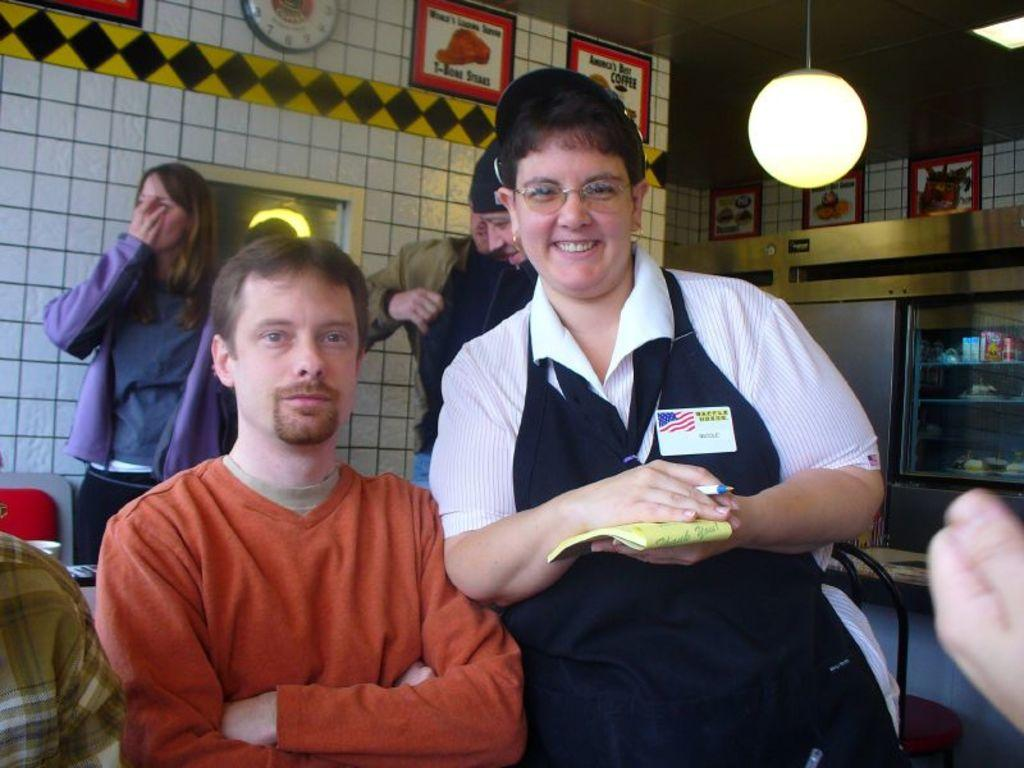How many people are in the image? There are people in the image. Can you describe the expression of one of the people? One person is smiling. What is the person holding in their hand? The person is holding a pen and a book. What can be seen on the wall in the image? There are pictures on the wall and a clock. What type of lighting is present in the image? There is a light in the image. What is visible in the distance in the image? There is a rack in the distance. What is the reason for the quiet atmosphere in the image? There is no indication of a quiet atmosphere in the image; the presence of people and a clock suggest that it might be a normal environment. 